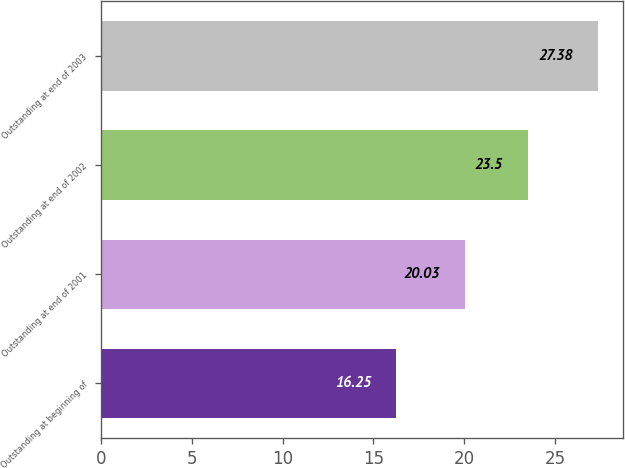<chart> <loc_0><loc_0><loc_500><loc_500><bar_chart><fcel>Outstanding at beginning of<fcel>Outstanding at end of 2001<fcel>Outstanding at end of 2002<fcel>Outstanding at end of 2003<nl><fcel>16.25<fcel>20.03<fcel>23.5<fcel>27.38<nl></chart> 